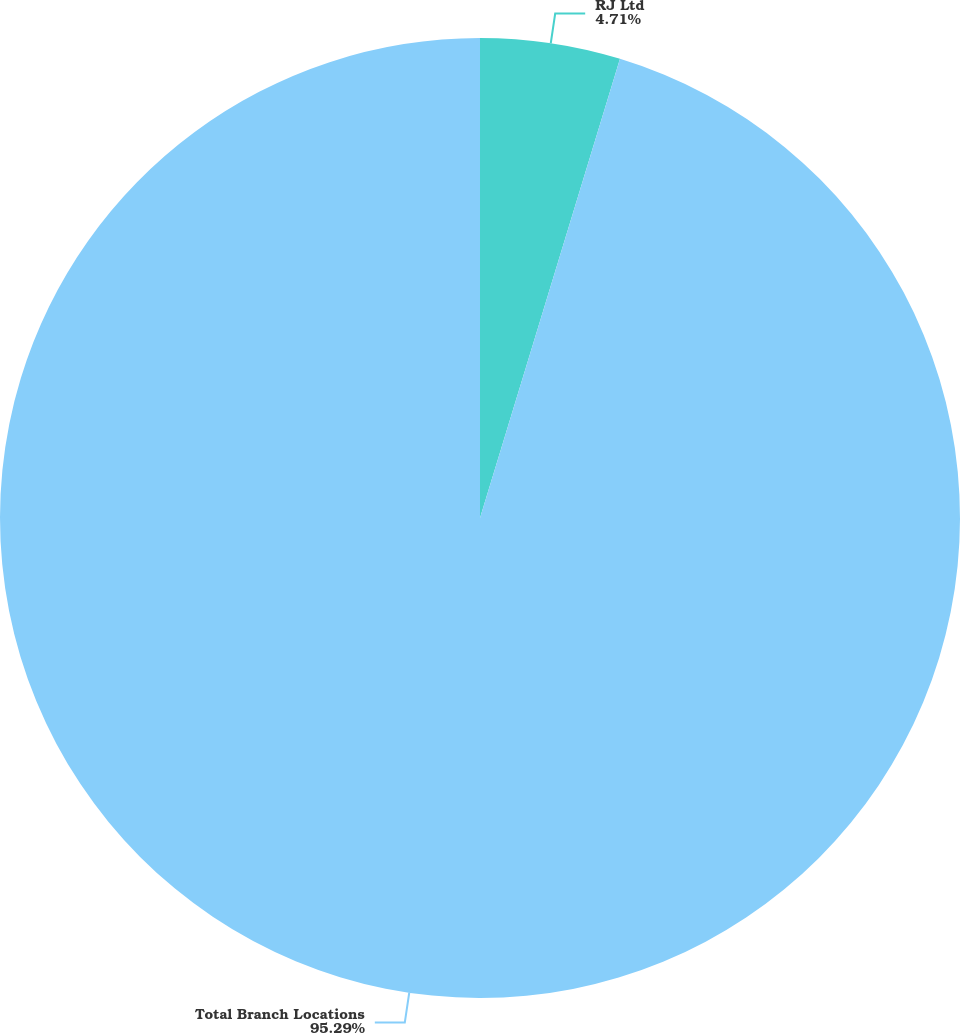Convert chart. <chart><loc_0><loc_0><loc_500><loc_500><pie_chart><fcel>RJ Ltd<fcel>Total Branch Locations<nl><fcel>4.71%<fcel>95.29%<nl></chart> 